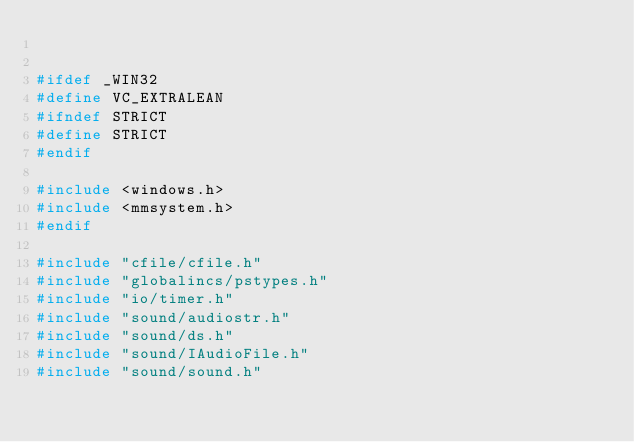Convert code to text. <code><loc_0><loc_0><loc_500><loc_500><_C++_>

#ifdef _WIN32
#define VC_EXTRALEAN
#ifndef STRICT
#define STRICT
#endif

#include <windows.h>
#include <mmsystem.h>
#endif

#include "cfile/cfile.h"
#include "globalincs/pstypes.h"
#include "io/timer.h"
#include "sound/audiostr.h"
#include "sound/ds.h"
#include "sound/IAudioFile.h"
#include "sound/sound.h"</code> 